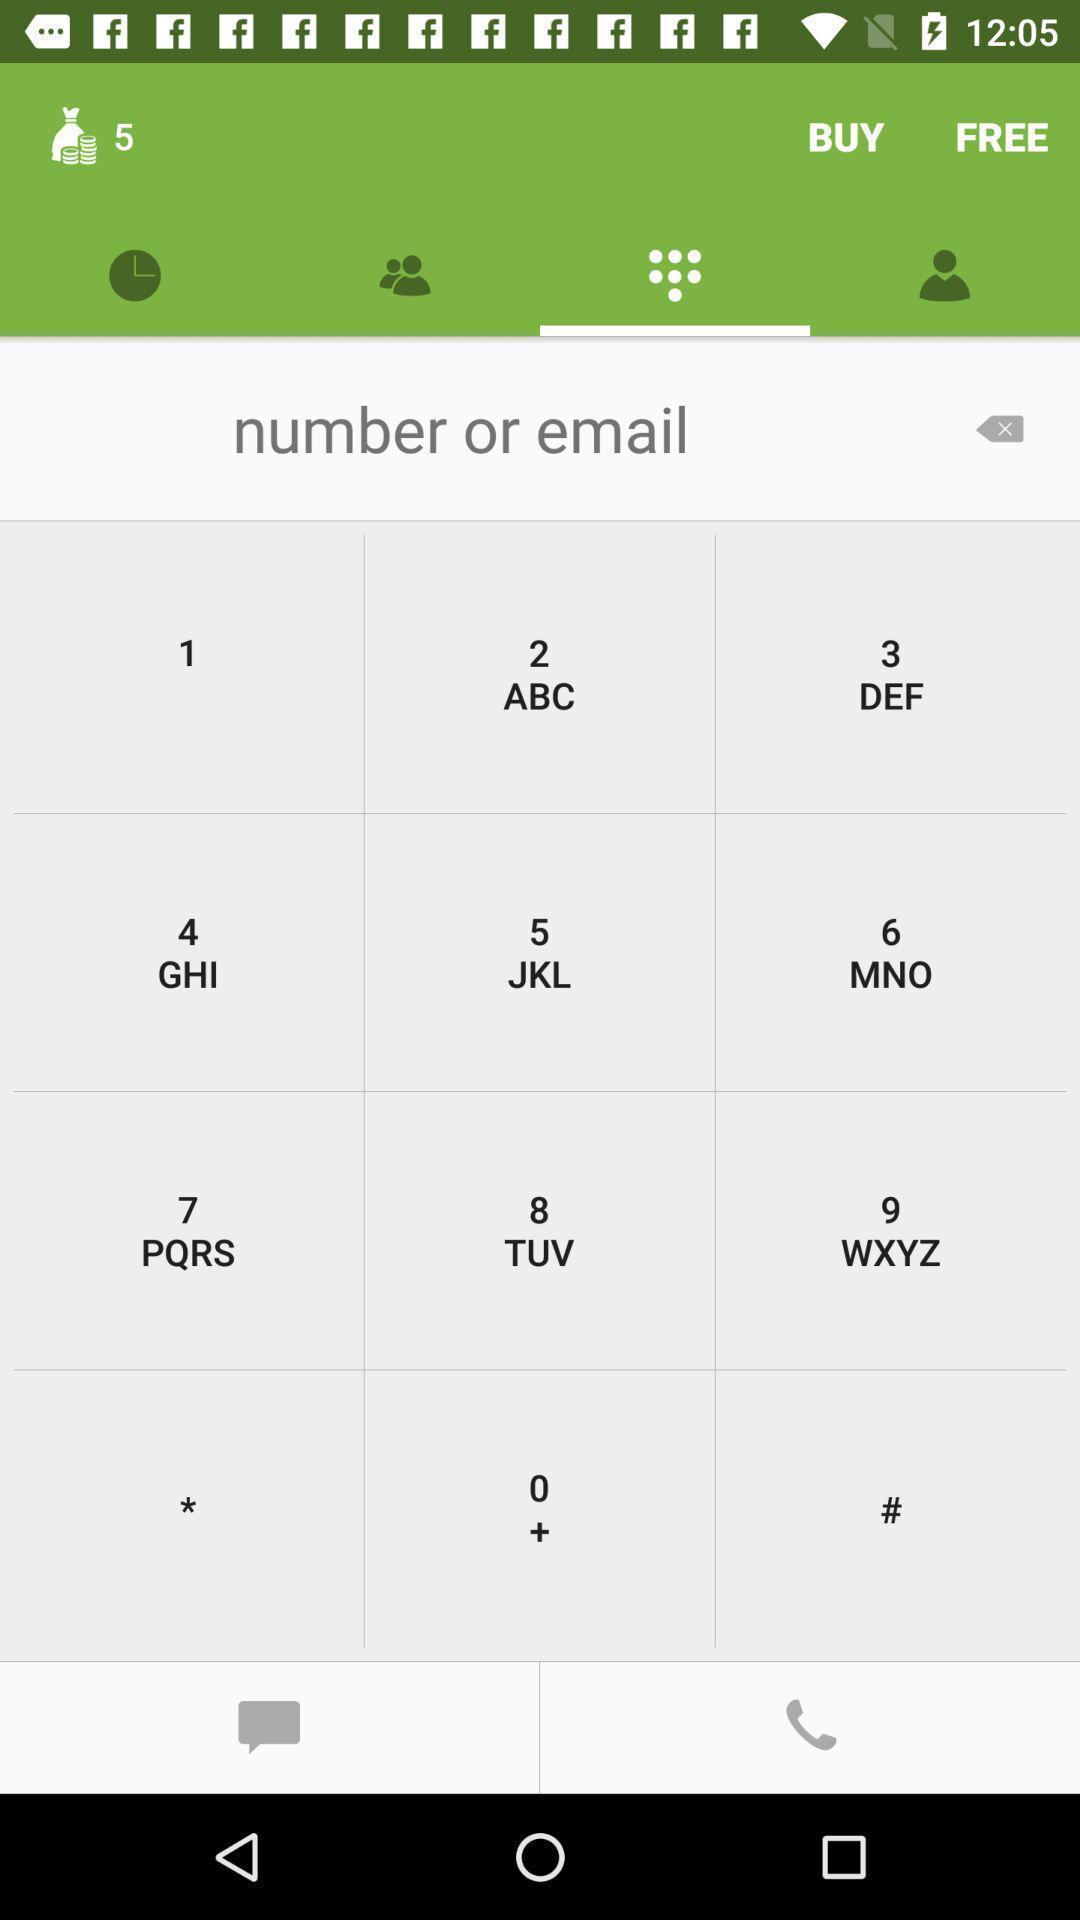What details can you identify in this image? Page with numbers and options to make a call. 